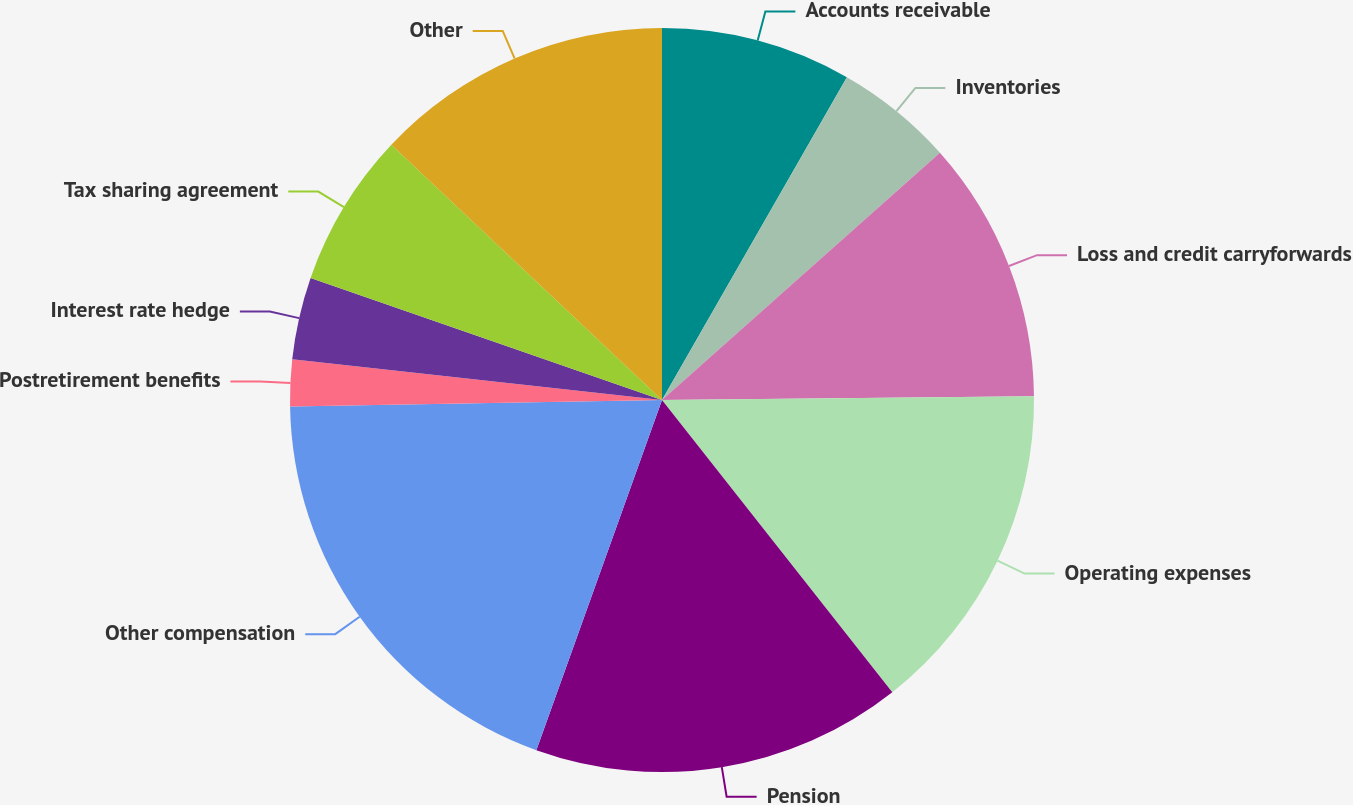Convert chart. <chart><loc_0><loc_0><loc_500><loc_500><pie_chart><fcel>Accounts receivable<fcel>Inventories<fcel>Loss and credit carryforwards<fcel>Operating expenses<fcel>Pension<fcel>Other compensation<fcel>Postretirement benefits<fcel>Interest rate hedge<fcel>Tax sharing agreement<fcel>Other<nl><fcel>8.28%<fcel>5.15%<fcel>11.41%<fcel>14.54%<fcel>16.11%<fcel>19.24%<fcel>2.02%<fcel>3.58%<fcel>6.71%<fcel>12.97%<nl></chart> 